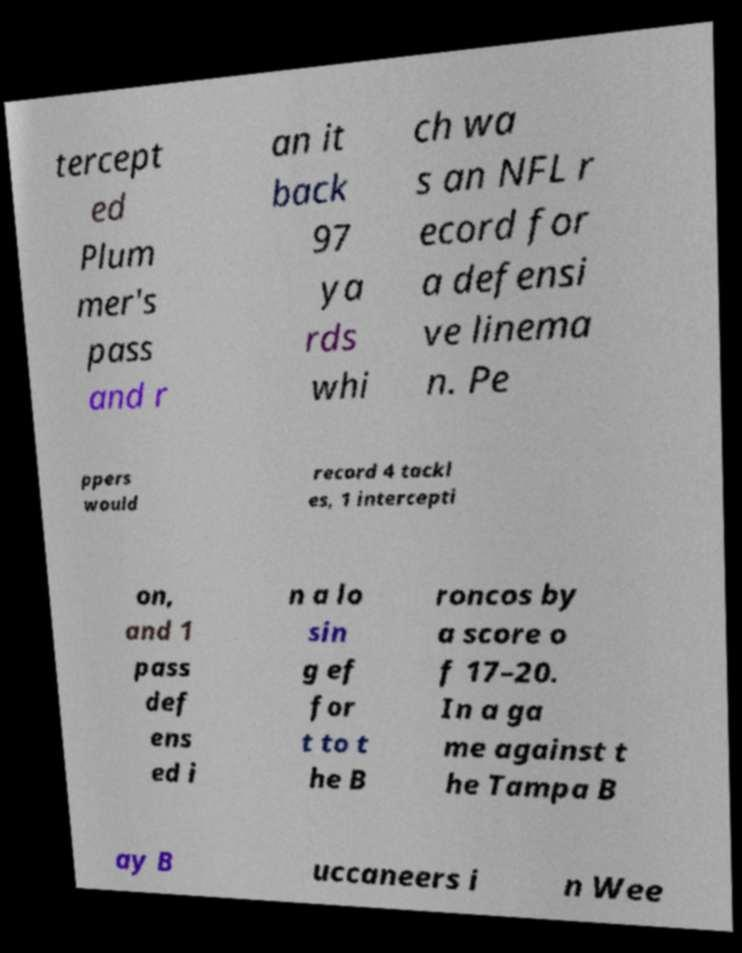What messages or text are displayed in this image? I need them in a readable, typed format. tercept ed Plum mer's pass and r an it back 97 ya rds whi ch wa s an NFL r ecord for a defensi ve linema n. Pe ppers would record 4 tackl es, 1 intercepti on, and 1 pass def ens ed i n a lo sin g ef for t to t he B roncos by a score o f 17–20. In a ga me against t he Tampa B ay B uccaneers i n Wee 